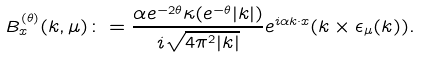Convert formula to latex. <formula><loc_0><loc_0><loc_500><loc_500>B ^ { ( \theta ) } _ { x } ( k , \mu ) \colon = \frac { \alpha e ^ { - 2 \theta } \kappa ( e ^ { - \theta } | k | ) } { i \sqrt { 4 \pi ^ { 2 } | k | } } e ^ { i \alpha k \cdot x } ( k \times \epsilon _ { \mu } ( k ) ) .</formula> 